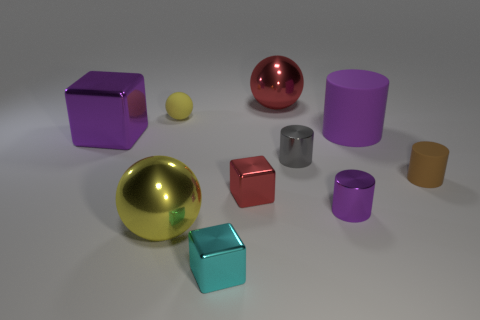Is the shape of the cyan metallic thing the same as the rubber object that is to the left of the gray metal object?
Your answer should be compact. No. How many cyan rubber balls are the same size as the red shiny cube?
Ensure brevity in your answer.  0. What is the material of the other large object that is the same shape as the yellow metallic object?
Provide a short and direct response. Metal. There is a ball in front of the small brown cylinder; is it the same color as the shiny block that is in front of the tiny purple cylinder?
Provide a short and direct response. No. There is a yellow object behind the large purple cylinder; what is its shape?
Provide a succinct answer. Sphere. The big metal cube is what color?
Your response must be concise. Purple. The big thing that is the same material as the tiny brown cylinder is what shape?
Offer a very short reply. Cylinder. There is a yellow thing in front of the purple metallic cylinder; is its size the same as the red shiny sphere?
Your answer should be compact. Yes. How many things are large things to the left of the yellow metal thing or tiny matte objects in front of the purple metal block?
Ensure brevity in your answer.  2. There is a small matte object right of the tiny gray shiny object; does it have the same color as the big cylinder?
Keep it short and to the point. No. 